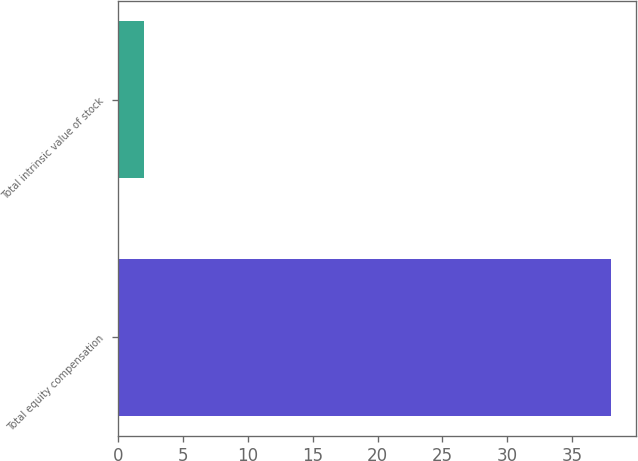Convert chart to OTSL. <chart><loc_0><loc_0><loc_500><loc_500><bar_chart><fcel>Total equity compensation<fcel>Total intrinsic value of stock<nl><fcel>38<fcel>2<nl></chart> 